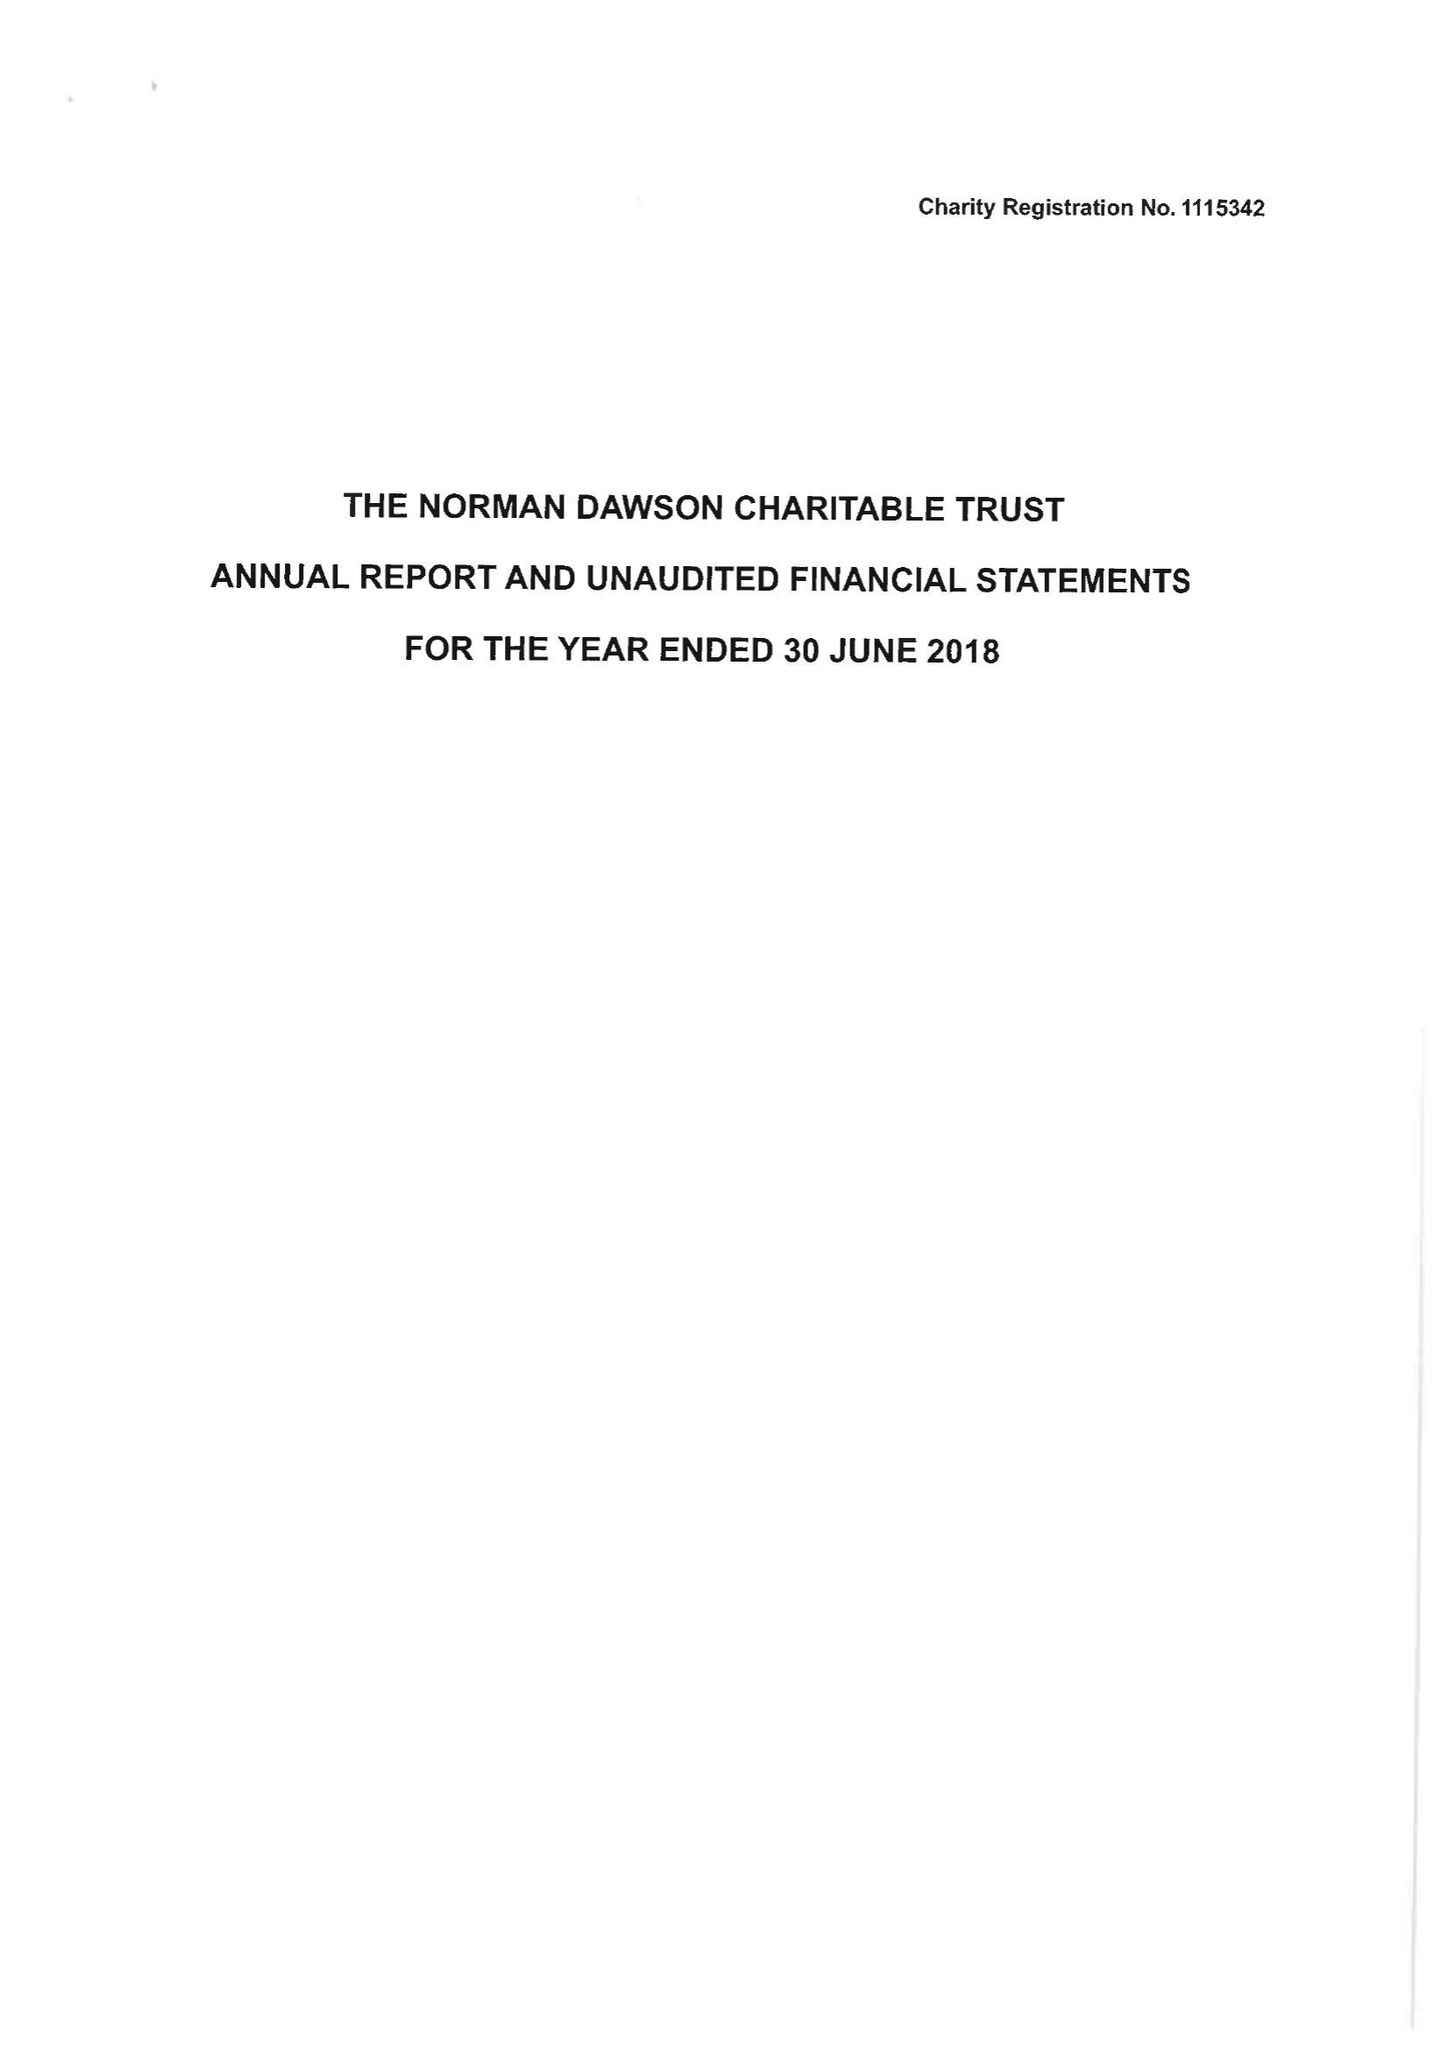What is the value for the address__postcode?
Answer the question using a single word or phrase. DY10 2SA 